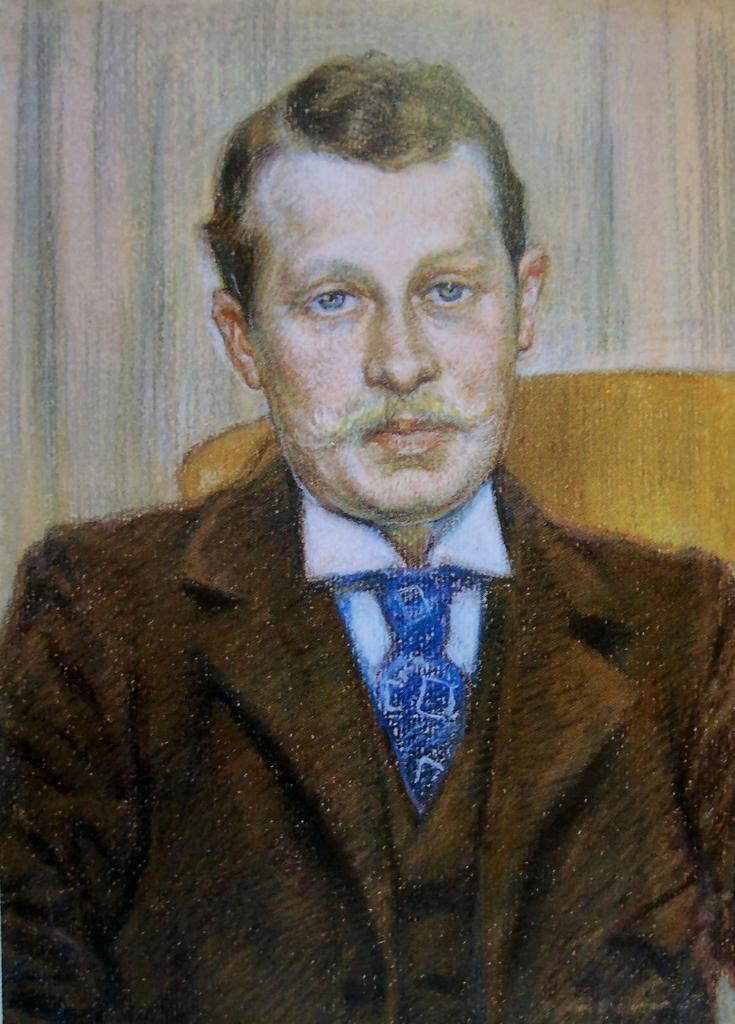What is depicted in the painting in the image? There is a painting of a person in the image. What color is the object that can be seen in the image? There is a yellow color object in the image. What type of structure is visible in the image? There is a wall in the image. How many passengers are visible in the image? There are no passengers present in the image; it features a painting of a person and a yellow object. Can you see any cracks in the wall in the image? The provided facts do not mention any cracks in the wall, so we cannot determine if any are present. 